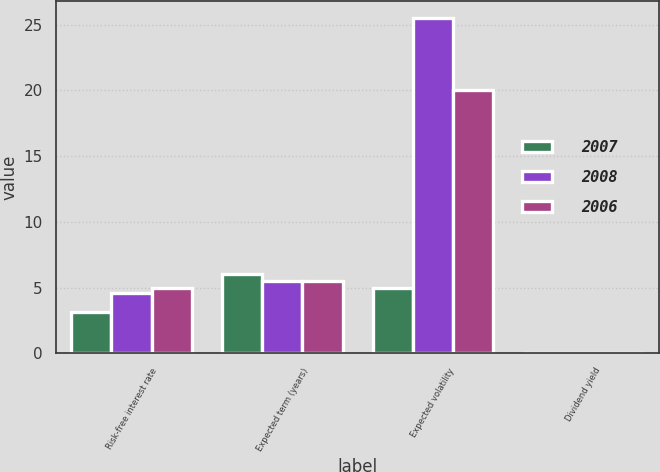Convert chart to OTSL. <chart><loc_0><loc_0><loc_500><loc_500><stacked_bar_chart><ecel><fcel>Risk-free interest rate<fcel>Expected term (years)<fcel>Expected volatility<fcel>Dividend yield<nl><fcel>2007<fcel>3.15<fcel>6.05<fcel>4.96<fcel>0<nl><fcel>2008<fcel>4.57<fcel>5.5<fcel>25.5<fcel>0<nl><fcel>2006<fcel>4.96<fcel>5.5<fcel>20<fcel>0<nl></chart> 